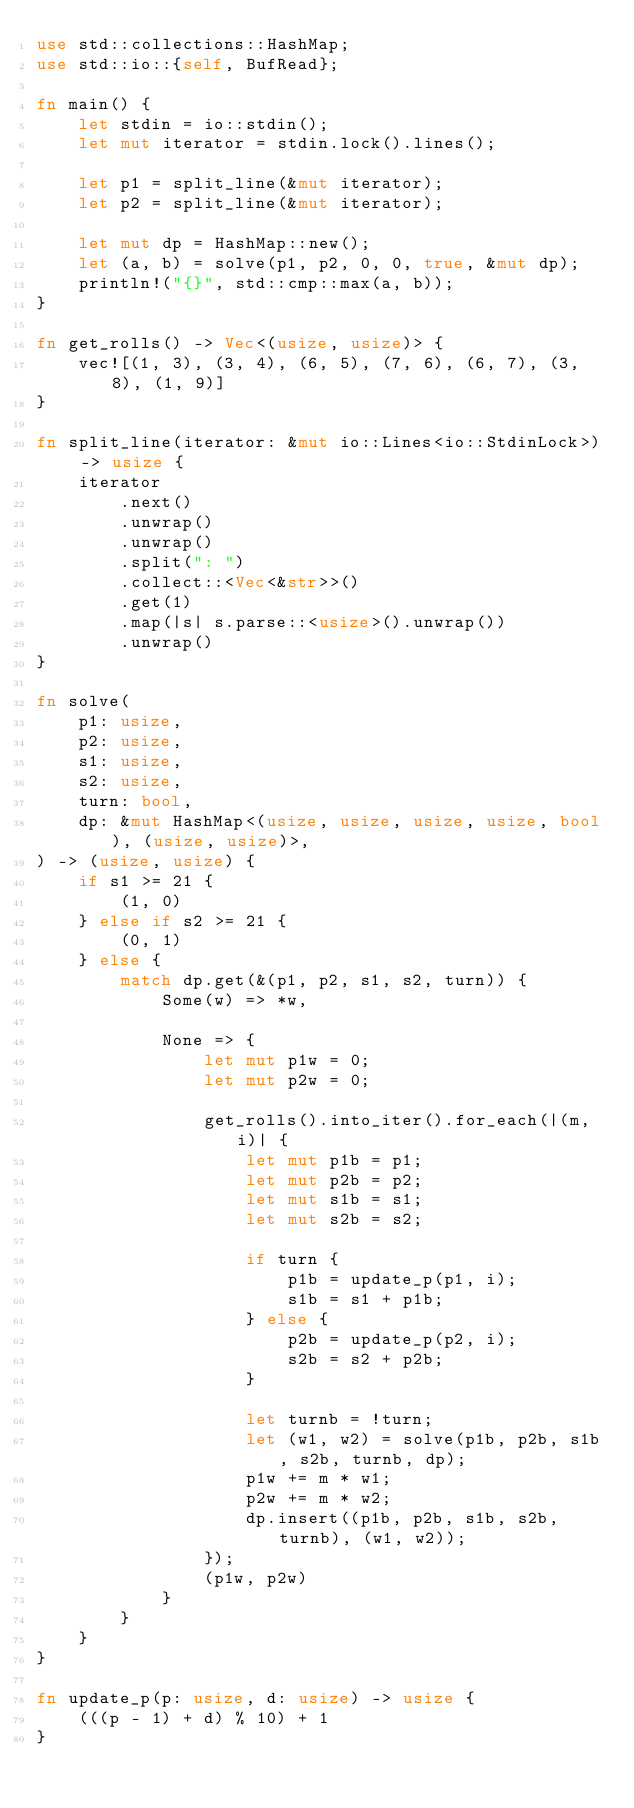<code> <loc_0><loc_0><loc_500><loc_500><_Rust_>use std::collections::HashMap;
use std::io::{self, BufRead};

fn main() {
    let stdin = io::stdin();
    let mut iterator = stdin.lock().lines();

    let p1 = split_line(&mut iterator);
    let p2 = split_line(&mut iterator);

    let mut dp = HashMap::new();
    let (a, b) = solve(p1, p2, 0, 0, true, &mut dp);
    println!("{}", std::cmp::max(a, b));
}

fn get_rolls() -> Vec<(usize, usize)> {
    vec![(1, 3), (3, 4), (6, 5), (7, 6), (6, 7), (3, 8), (1, 9)]
}

fn split_line(iterator: &mut io::Lines<io::StdinLock>) -> usize {
    iterator
        .next()
        .unwrap()
        .unwrap()
        .split(": ")
        .collect::<Vec<&str>>()
        .get(1)
        .map(|s| s.parse::<usize>().unwrap())
        .unwrap()
}

fn solve(
    p1: usize,
    p2: usize,
    s1: usize,
    s2: usize,
    turn: bool,
    dp: &mut HashMap<(usize, usize, usize, usize, bool), (usize, usize)>,
) -> (usize, usize) {
    if s1 >= 21 {
        (1, 0)
    } else if s2 >= 21 {
        (0, 1)
    } else {
        match dp.get(&(p1, p2, s1, s2, turn)) {
            Some(w) => *w,

            None => {
                let mut p1w = 0;
                let mut p2w = 0;

                get_rolls().into_iter().for_each(|(m, i)| {
                    let mut p1b = p1;
                    let mut p2b = p2;
                    let mut s1b = s1;
                    let mut s2b = s2;

                    if turn {
                        p1b = update_p(p1, i);
                        s1b = s1 + p1b;
                    } else {
                        p2b = update_p(p2, i);
                        s2b = s2 + p2b;
                    }

                    let turnb = !turn;
                    let (w1, w2) = solve(p1b, p2b, s1b, s2b, turnb, dp);
                    p1w += m * w1;
                    p2w += m * w2;
                    dp.insert((p1b, p2b, s1b, s2b, turnb), (w1, w2));
                });
                (p1w, p2w)
            }
        }
    }
}

fn update_p(p: usize, d: usize) -> usize {
    (((p - 1) + d) % 10) + 1
}
</code> 